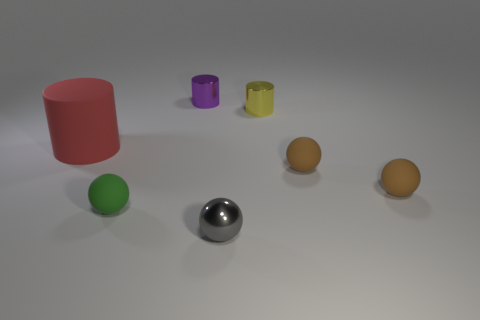Subtract 1 spheres. How many spheres are left? 3 Add 1 tiny gray metallic things. How many objects exist? 8 Subtract all balls. How many objects are left? 3 Subtract all metallic cylinders. Subtract all small cyan shiny objects. How many objects are left? 5 Add 4 gray shiny balls. How many gray shiny balls are left? 5 Add 6 large blue blocks. How many large blue blocks exist? 6 Subtract 0 gray blocks. How many objects are left? 7 